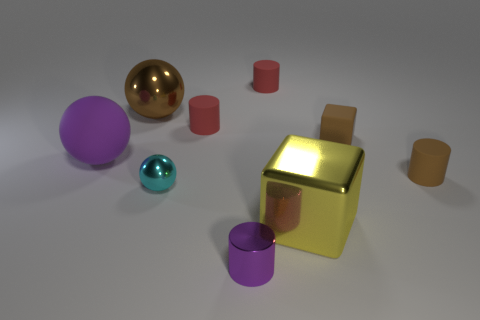Subtract all tiny brown rubber cylinders. How many cylinders are left? 3 Subtract all brown cylinders. How many cylinders are left? 3 Subtract all balls. How many objects are left? 6 Subtract 2 cylinders. How many cylinders are left? 2 Subtract all blue spheres. How many brown cylinders are left? 1 Subtract all tiny brown metal cubes. Subtract all cubes. How many objects are left? 7 Add 1 cyan metallic spheres. How many cyan metallic spheres are left? 2 Add 9 cyan metallic objects. How many cyan metallic objects exist? 10 Subtract 0 blue blocks. How many objects are left? 9 Subtract all yellow balls. Subtract all purple cylinders. How many balls are left? 3 